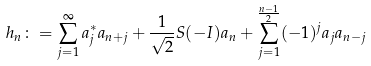<formula> <loc_0><loc_0><loc_500><loc_500>h _ { n } \colon = \sum _ { j = 1 } ^ { \infty } a _ { j } ^ { \ast } a _ { n + j } + \frac { 1 } { \sqrt { 2 } } S ( - I ) a _ { n } + \sum _ { j = 1 } ^ { \frac { n - 1 } { 2 } } ( - 1 ) ^ { j } a _ { j } a _ { n - j }</formula> 